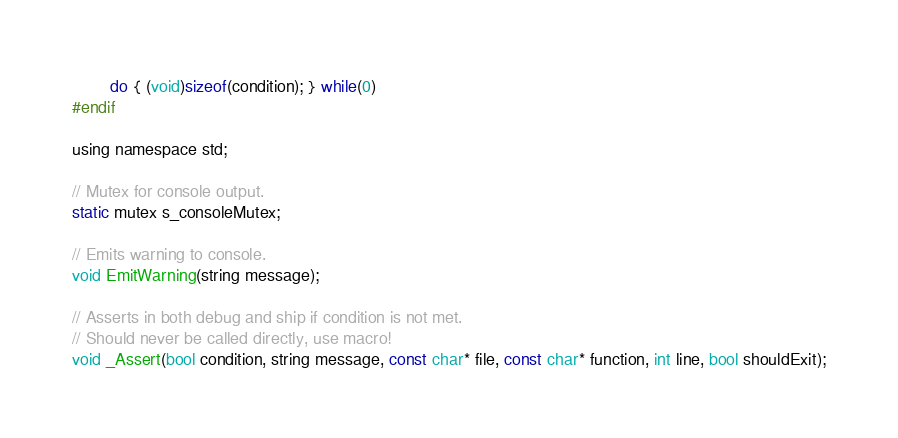Convert code to text. <code><loc_0><loc_0><loc_500><loc_500><_Cuda_>		do { (void)sizeof(condition); } while(0)
#endif

using namespace std;

// Mutex for console output.
static mutex s_consoleMutex;

// Emits warning to console.
void EmitWarning(string message);

// Asserts in both debug and ship if condition is not met.
// Should never be called directly, use macro!
void _Assert(bool condition, string message, const char* file, const char* function, int line, bool shouldExit);</code> 